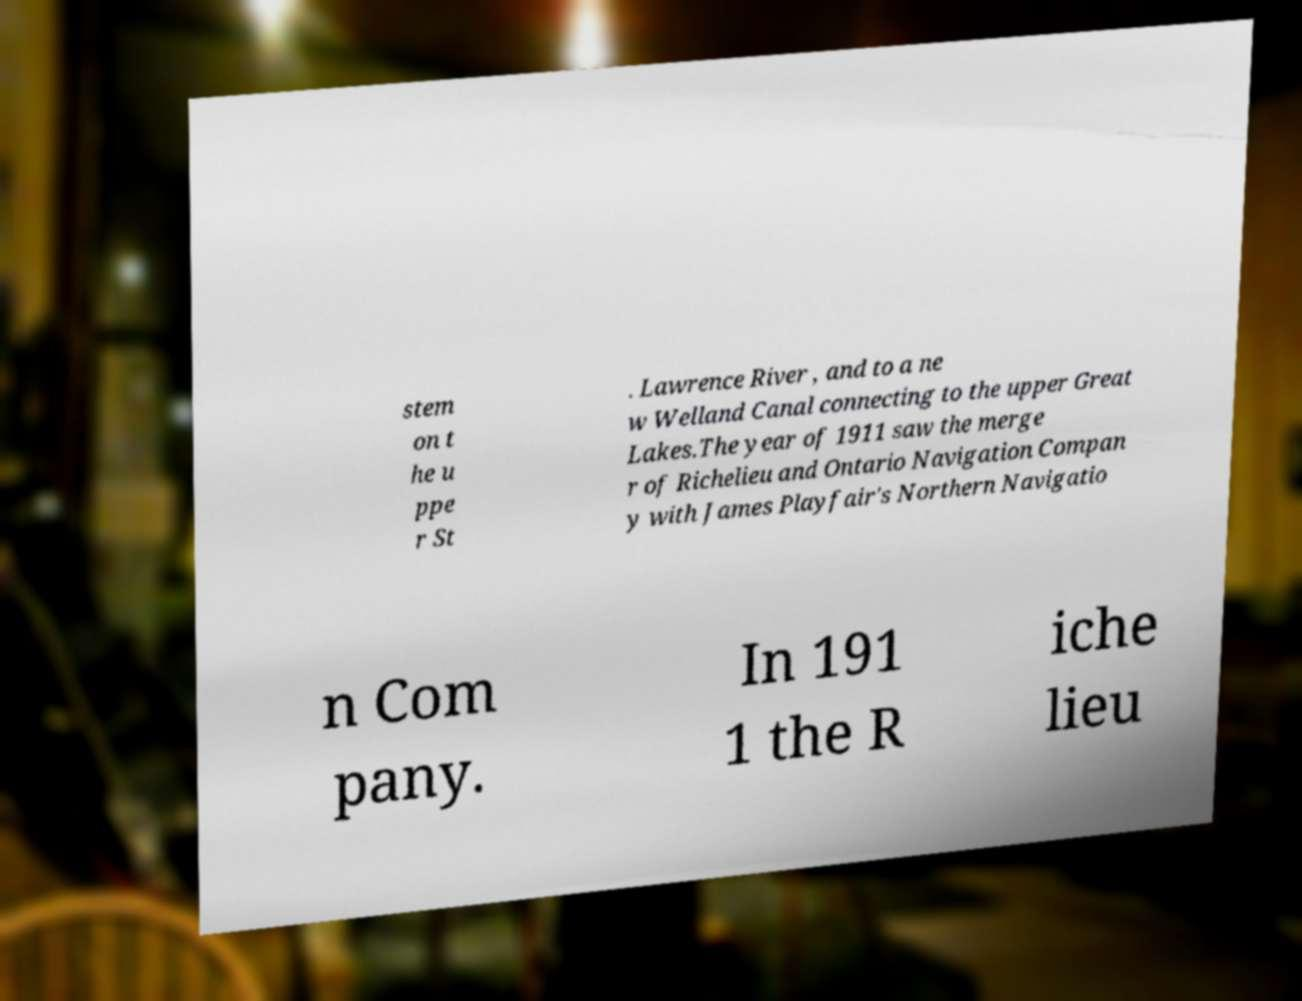There's text embedded in this image that I need extracted. Can you transcribe it verbatim? stem on t he u ppe r St . Lawrence River , and to a ne w Welland Canal connecting to the upper Great Lakes.The year of 1911 saw the merge r of Richelieu and Ontario Navigation Compan y with James Playfair's Northern Navigatio n Com pany. In 191 1 the R iche lieu 